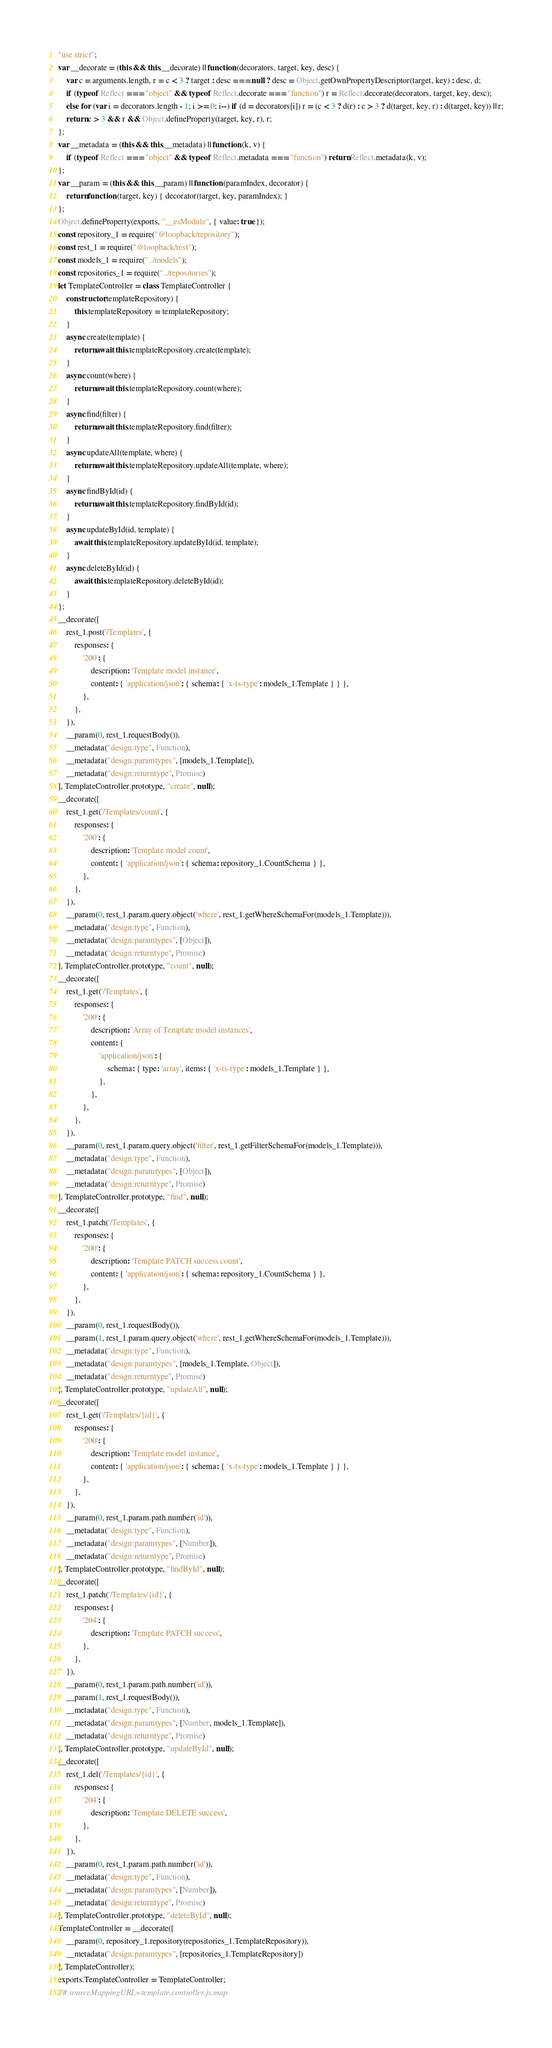<code> <loc_0><loc_0><loc_500><loc_500><_JavaScript_>"use strict";
var __decorate = (this && this.__decorate) || function (decorators, target, key, desc) {
    var c = arguments.length, r = c < 3 ? target : desc === null ? desc = Object.getOwnPropertyDescriptor(target, key) : desc, d;
    if (typeof Reflect === "object" && typeof Reflect.decorate === "function") r = Reflect.decorate(decorators, target, key, desc);
    else for (var i = decorators.length - 1; i >= 0; i--) if (d = decorators[i]) r = (c < 3 ? d(r) : c > 3 ? d(target, key, r) : d(target, key)) || r;
    return c > 3 && r && Object.defineProperty(target, key, r), r;
};
var __metadata = (this && this.__metadata) || function (k, v) {
    if (typeof Reflect === "object" && typeof Reflect.metadata === "function") return Reflect.metadata(k, v);
};
var __param = (this && this.__param) || function (paramIndex, decorator) {
    return function (target, key) { decorator(target, key, paramIndex); }
};
Object.defineProperty(exports, "__esModule", { value: true });
const repository_1 = require("@loopback/repository");
const rest_1 = require("@loopback/rest");
const models_1 = require("../models");
const repositories_1 = require("../repositories");
let TemplateController = class TemplateController {
    constructor(templateRepository) {
        this.templateRepository = templateRepository;
    }
    async create(template) {
        return await this.templateRepository.create(template);
    }
    async count(where) {
        return await this.templateRepository.count(where);
    }
    async find(filter) {
        return await this.templateRepository.find(filter);
    }
    async updateAll(template, where) {
        return await this.templateRepository.updateAll(template, where);
    }
    async findById(id) {
        return await this.templateRepository.findById(id);
    }
    async updateById(id, template) {
        await this.templateRepository.updateById(id, template);
    }
    async deleteById(id) {
        await this.templateRepository.deleteById(id);
    }
};
__decorate([
    rest_1.post('/Templates', {
        responses: {
            '200': {
                description: 'Template model instance',
                content: { 'application/json': { schema: { 'x-ts-type': models_1.Template } } },
            },
        },
    }),
    __param(0, rest_1.requestBody()),
    __metadata("design:type", Function),
    __metadata("design:paramtypes", [models_1.Template]),
    __metadata("design:returntype", Promise)
], TemplateController.prototype, "create", null);
__decorate([
    rest_1.get('/Templates/count', {
        responses: {
            '200': {
                description: 'Template model count',
                content: { 'application/json': { schema: repository_1.CountSchema } },
            },
        },
    }),
    __param(0, rest_1.param.query.object('where', rest_1.getWhereSchemaFor(models_1.Template))),
    __metadata("design:type", Function),
    __metadata("design:paramtypes", [Object]),
    __metadata("design:returntype", Promise)
], TemplateController.prototype, "count", null);
__decorate([
    rest_1.get('/Templates', {
        responses: {
            '200': {
                description: 'Array of Template model instances',
                content: {
                    'application/json': {
                        schema: { type: 'array', items: { 'x-ts-type': models_1.Template } },
                    },
                },
            },
        },
    }),
    __param(0, rest_1.param.query.object('filter', rest_1.getFilterSchemaFor(models_1.Template))),
    __metadata("design:type", Function),
    __metadata("design:paramtypes", [Object]),
    __metadata("design:returntype", Promise)
], TemplateController.prototype, "find", null);
__decorate([
    rest_1.patch('/Templates', {
        responses: {
            '200': {
                description: 'Template PATCH success count',
                content: { 'application/json': { schema: repository_1.CountSchema } },
            },
        },
    }),
    __param(0, rest_1.requestBody()),
    __param(1, rest_1.param.query.object('where', rest_1.getWhereSchemaFor(models_1.Template))),
    __metadata("design:type", Function),
    __metadata("design:paramtypes", [models_1.Template, Object]),
    __metadata("design:returntype", Promise)
], TemplateController.prototype, "updateAll", null);
__decorate([
    rest_1.get('/Templates/{id}', {
        responses: {
            '200': {
                description: 'Template model instance',
                content: { 'application/json': { schema: { 'x-ts-type': models_1.Template } } },
            },
        },
    }),
    __param(0, rest_1.param.path.number('id')),
    __metadata("design:type", Function),
    __metadata("design:paramtypes", [Number]),
    __metadata("design:returntype", Promise)
], TemplateController.prototype, "findById", null);
__decorate([
    rest_1.patch('/Templates/{id}', {
        responses: {
            '204': {
                description: 'Template PATCH success',
            },
        },
    }),
    __param(0, rest_1.param.path.number('id')),
    __param(1, rest_1.requestBody()),
    __metadata("design:type", Function),
    __metadata("design:paramtypes", [Number, models_1.Template]),
    __metadata("design:returntype", Promise)
], TemplateController.prototype, "updateById", null);
__decorate([
    rest_1.del('/Templates/{id}', {
        responses: {
            '204': {
                description: 'Template DELETE success',
            },
        },
    }),
    __param(0, rest_1.param.path.number('id')),
    __metadata("design:type", Function),
    __metadata("design:paramtypes", [Number]),
    __metadata("design:returntype", Promise)
], TemplateController.prototype, "deleteById", null);
TemplateController = __decorate([
    __param(0, repository_1.repository(repositories_1.TemplateRepository)),
    __metadata("design:paramtypes", [repositories_1.TemplateRepository])
], TemplateController);
exports.TemplateController = TemplateController;
//# sourceMappingURL=template.controller.js.map</code> 